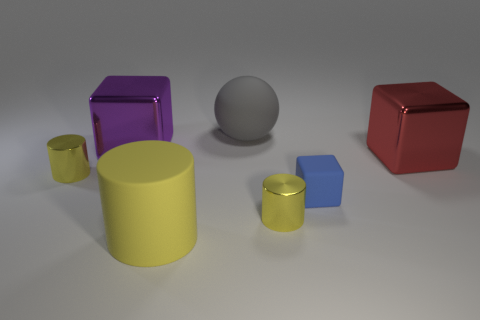There is a purple metal cube; what number of blue objects are behind it? After examining the image closely, there are no blue objects located behind the purple metal cube. 